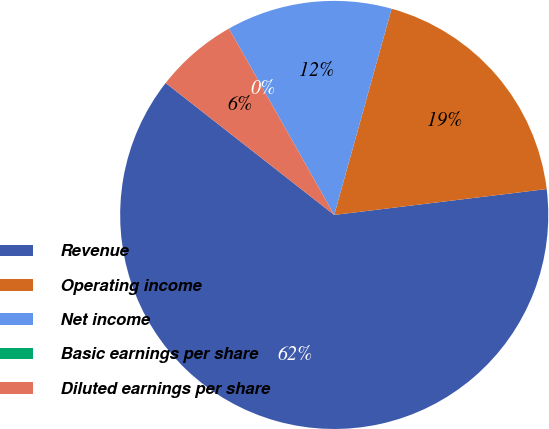Convert chart to OTSL. <chart><loc_0><loc_0><loc_500><loc_500><pie_chart><fcel>Revenue<fcel>Operating income<fcel>Net income<fcel>Basic earnings per share<fcel>Diluted earnings per share<nl><fcel>62.5%<fcel>18.75%<fcel>12.5%<fcel>0.0%<fcel>6.25%<nl></chart> 